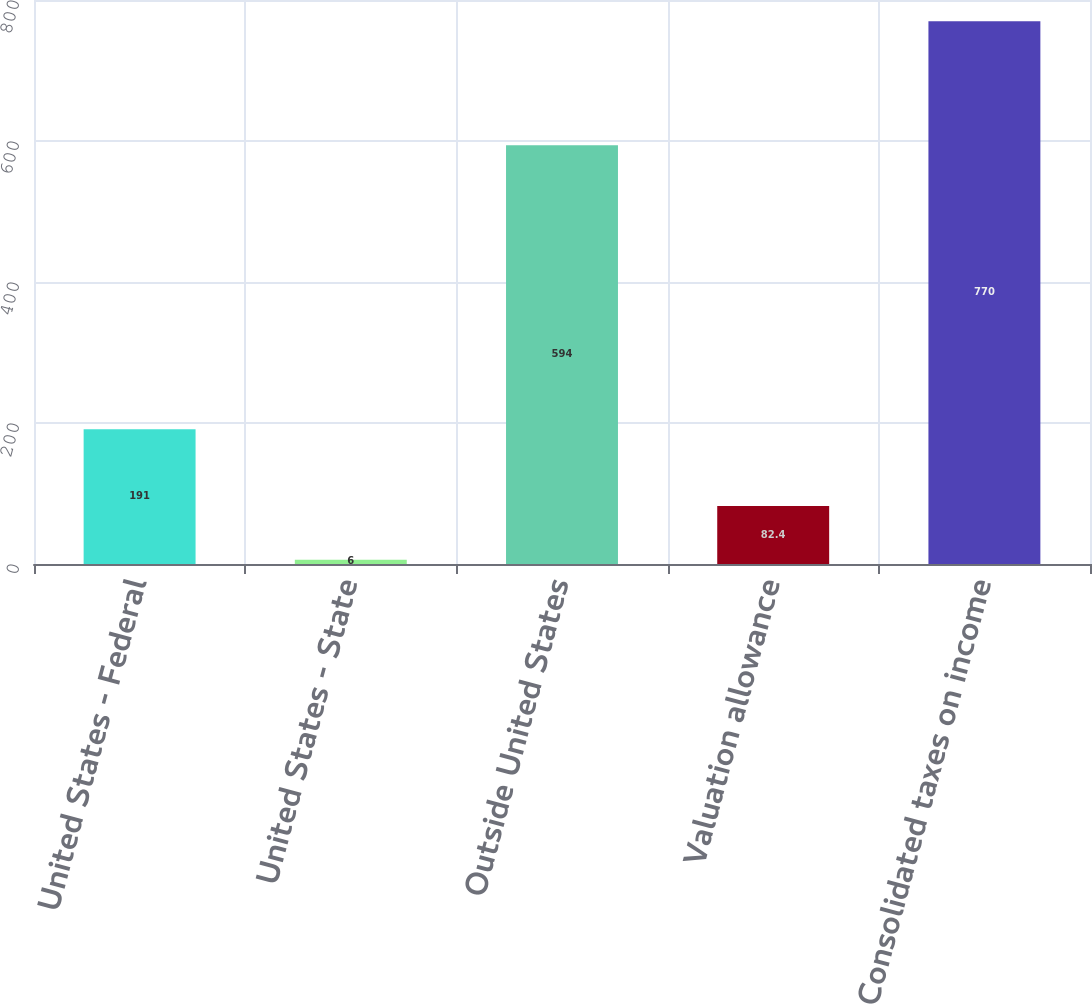Convert chart to OTSL. <chart><loc_0><loc_0><loc_500><loc_500><bar_chart><fcel>United States - Federal<fcel>United States - State<fcel>Outside United States<fcel>Valuation allowance<fcel>Consolidated taxes on income<nl><fcel>191<fcel>6<fcel>594<fcel>82.4<fcel>770<nl></chart> 